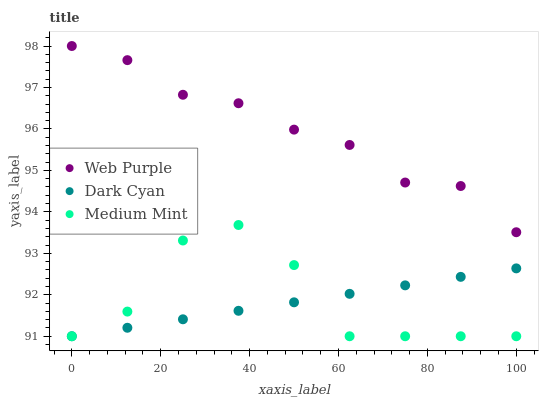Does Dark Cyan have the minimum area under the curve?
Answer yes or no. Yes. Does Web Purple have the maximum area under the curve?
Answer yes or no. Yes. Does Medium Mint have the minimum area under the curve?
Answer yes or no. No. Does Medium Mint have the maximum area under the curve?
Answer yes or no. No. Is Dark Cyan the smoothest?
Answer yes or no. Yes. Is Medium Mint the roughest?
Answer yes or no. Yes. Is Web Purple the smoothest?
Answer yes or no. No. Is Web Purple the roughest?
Answer yes or no. No. Does Dark Cyan have the lowest value?
Answer yes or no. Yes. Does Web Purple have the lowest value?
Answer yes or no. No. Does Web Purple have the highest value?
Answer yes or no. Yes. Does Medium Mint have the highest value?
Answer yes or no. No. Is Dark Cyan less than Web Purple?
Answer yes or no. Yes. Is Web Purple greater than Dark Cyan?
Answer yes or no. Yes. Does Medium Mint intersect Dark Cyan?
Answer yes or no. Yes. Is Medium Mint less than Dark Cyan?
Answer yes or no. No. Is Medium Mint greater than Dark Cyan?
Answer yes or no. No. Does Dark Cyan intersect Web Purple?
Answer yes or no. No. 